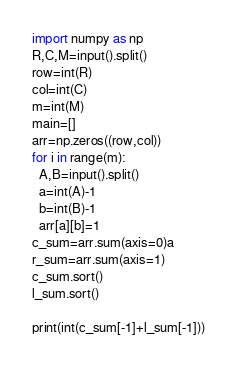Convert code to text. <code><loc_0><loc_0><loc_500><loc_500><_Python_>import numpy as np
R,C,M=input().split()
row=int(R)
col=int(C)
m=int(M)
main=[]
arr=np.zeros((row,col))
for i in range(m):
  A,B=input().split()
  a=int(A)-1
  b=int(B)-1
  arr[a][b]=1
c_sum=arr.sum(axis=0)a
r_sum=arr.sum(axis=1)
c_sum.sort()
l_sum.sort()

print(int(c_sum[-1]+l_sum[-1]))</code> 